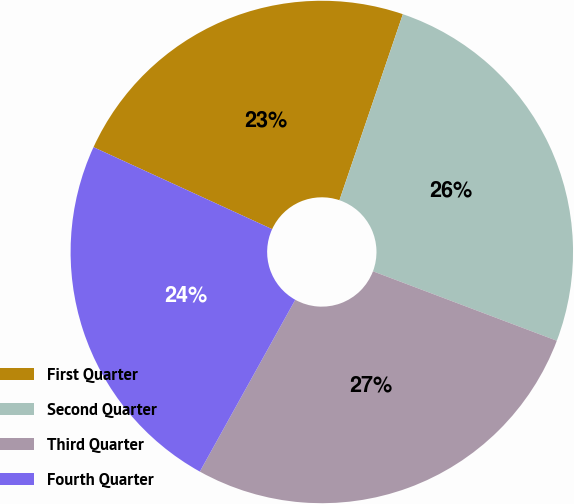Convert chart. <chart><loc_0><loc_0><loc_500><loc_500><pie_chart><fcel>First Quarter<fcel>Second Quarter<fcel>Third Quarter<fcel>Fourth Quarter<nl><fcel>23.38%<fcel>25.52%<fcel>27.32%<fcel>23.78%<nl></chart> 